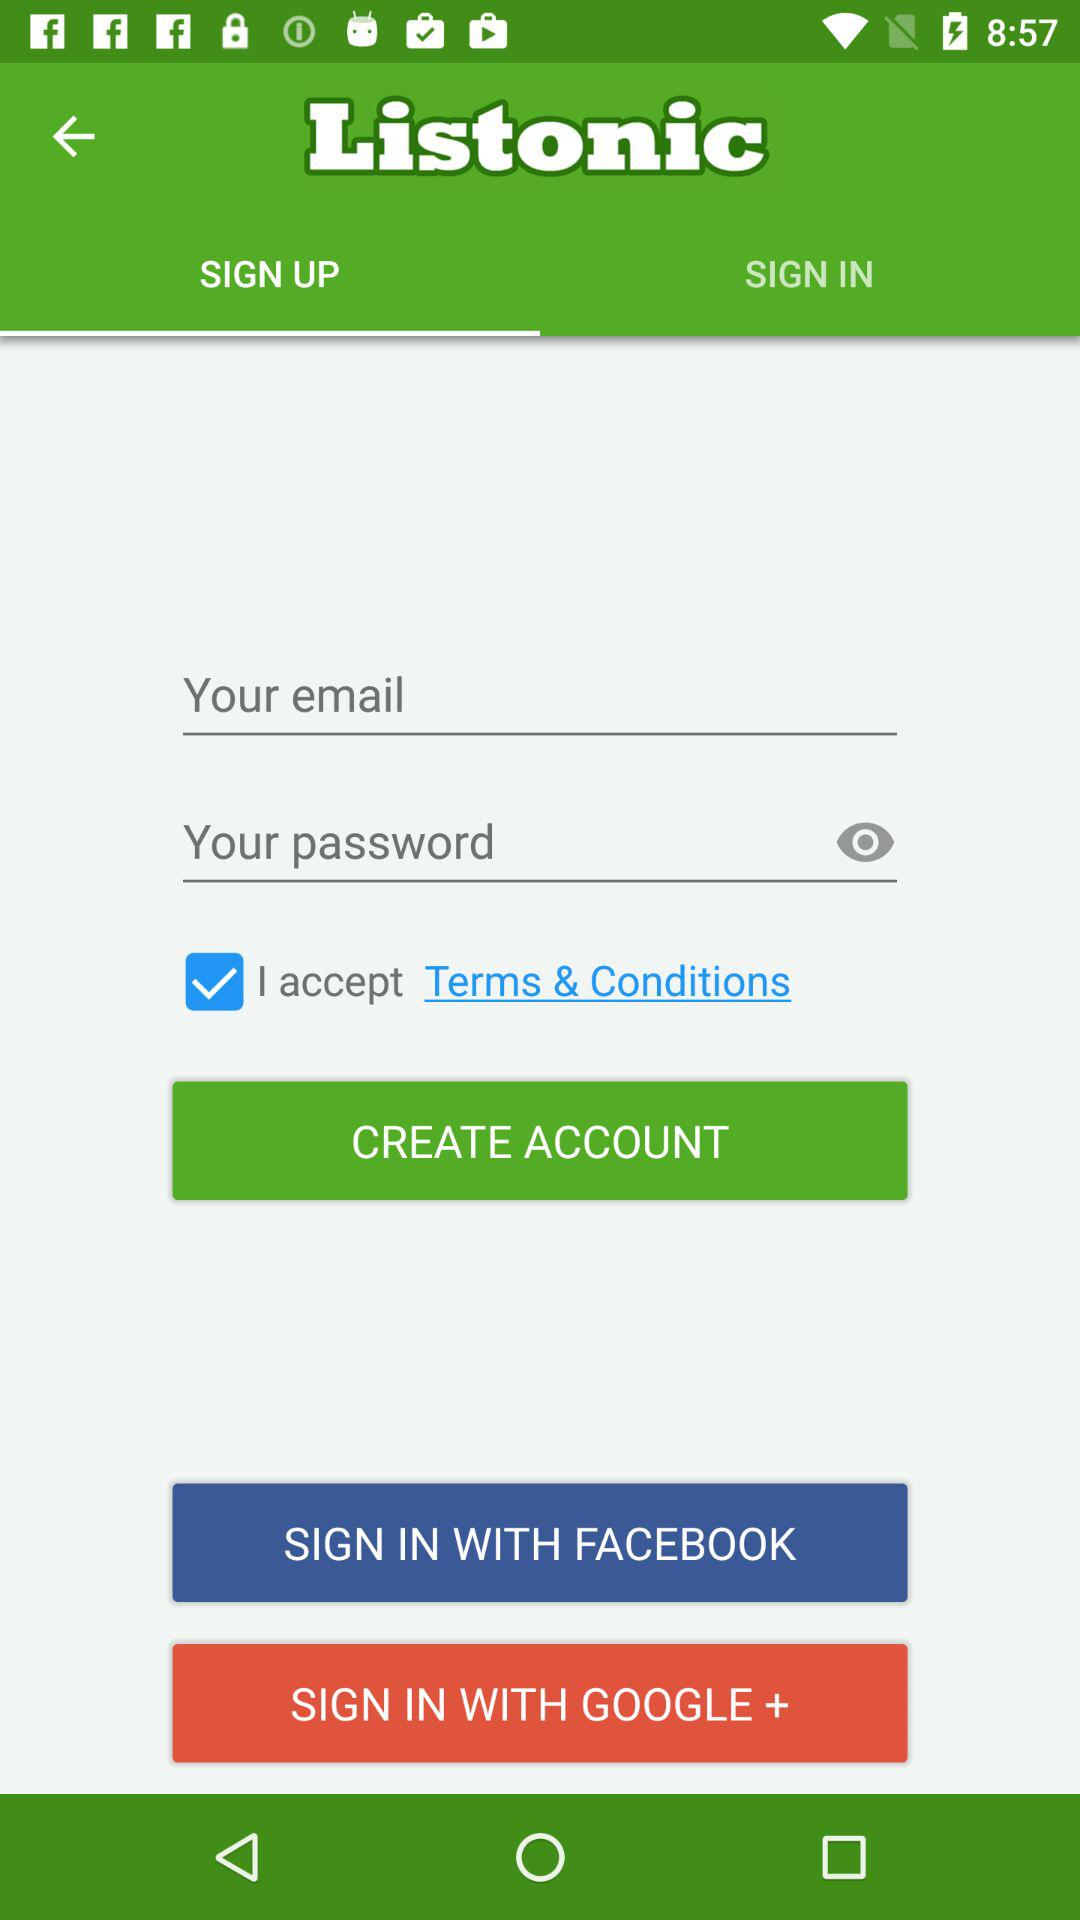Which accounts can I use to sign in? The accounts are "FACEBOOK" and "GOOGLE+". 